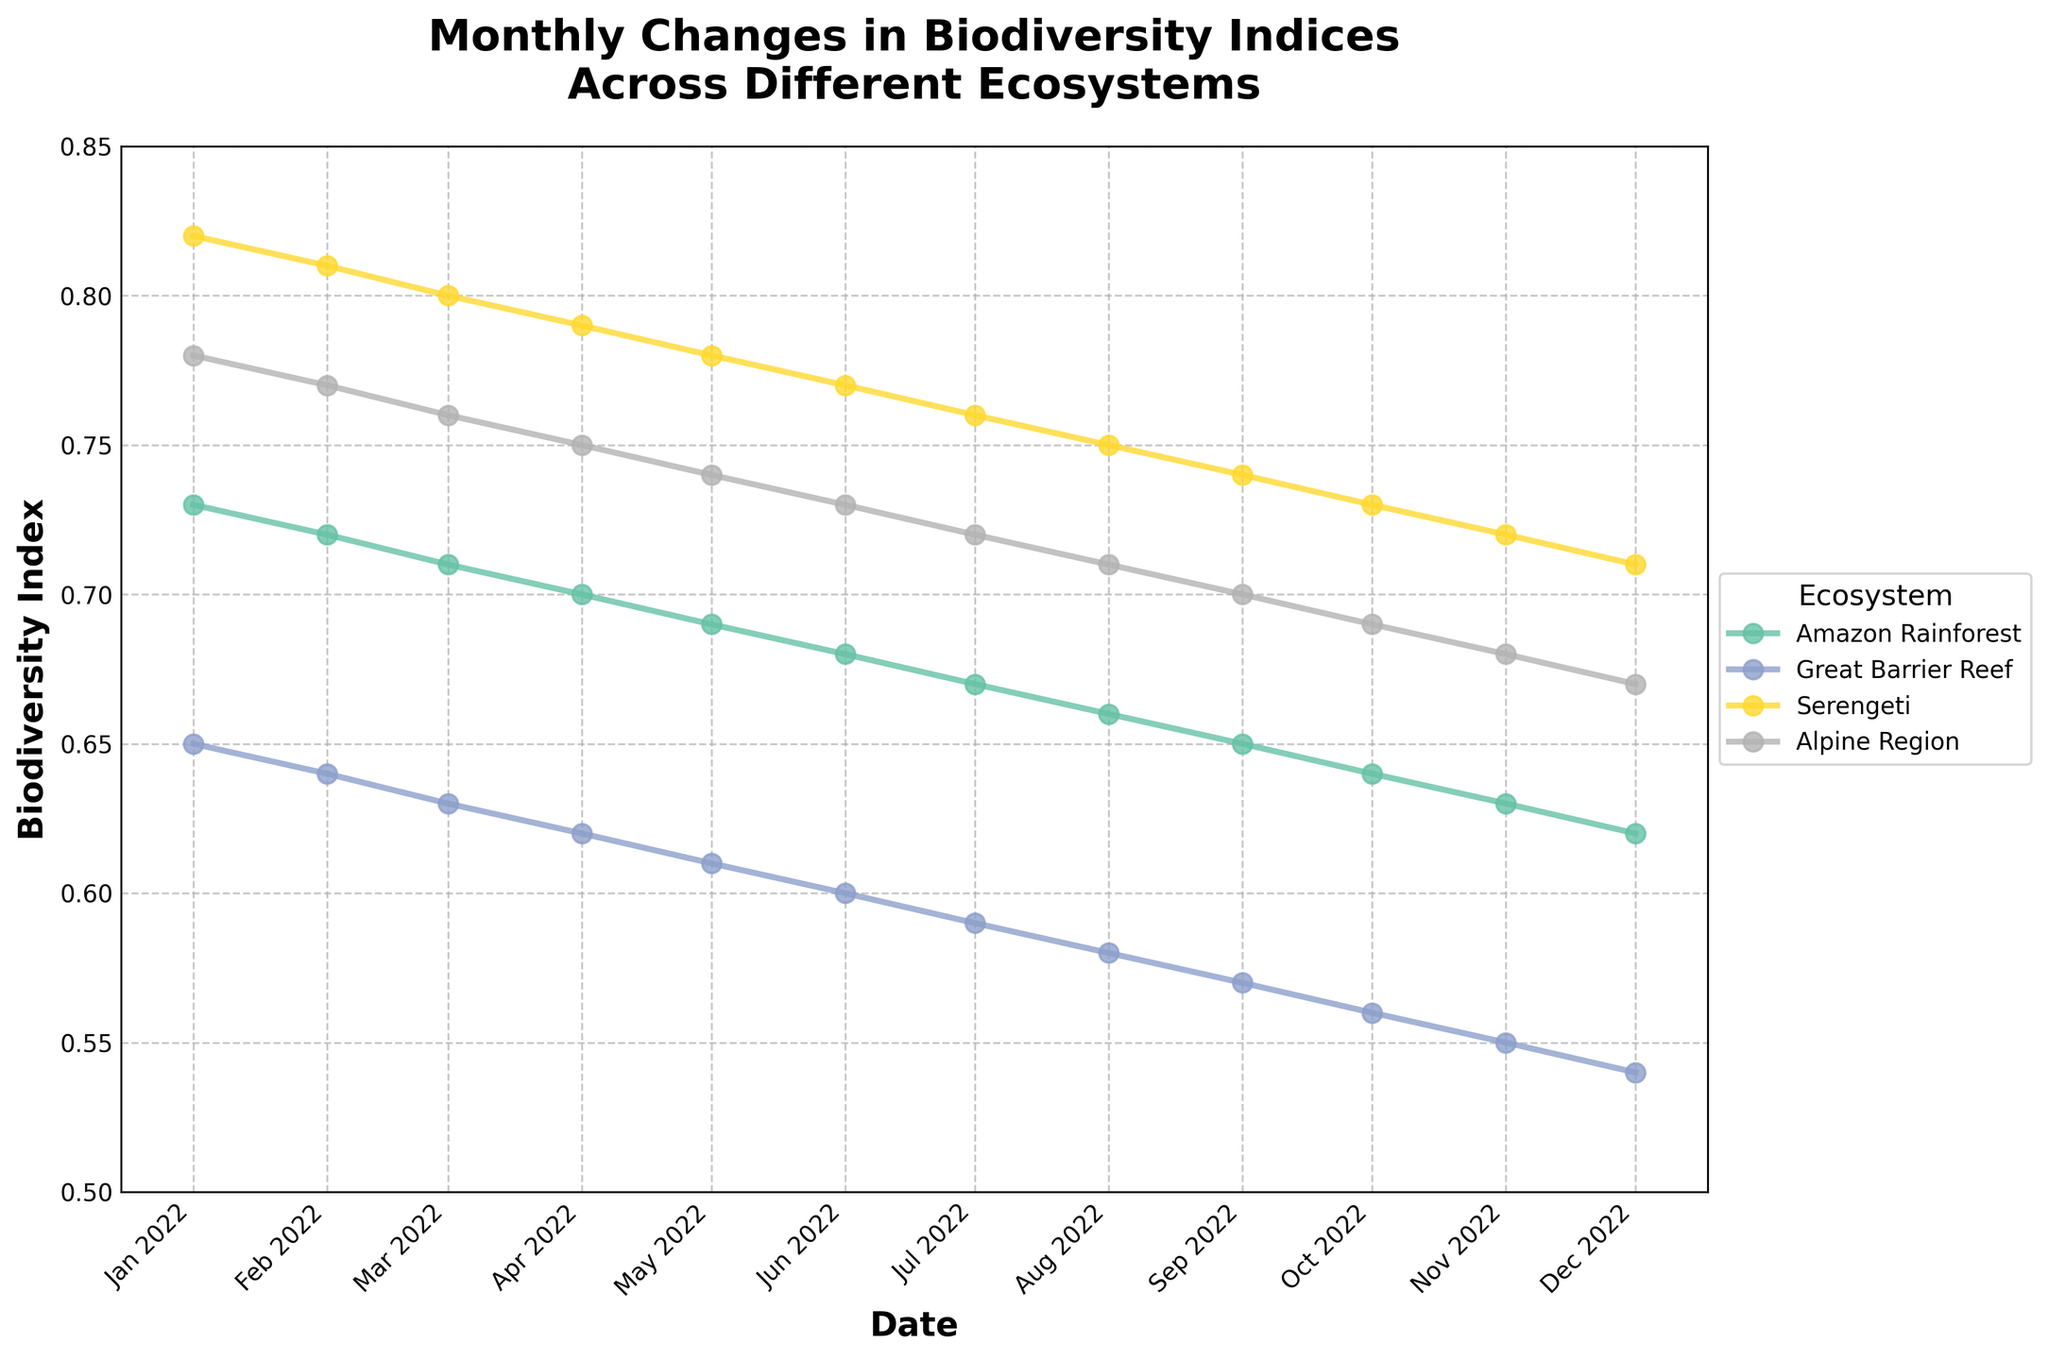What is the title of the plot? The title of the plot is shown at the top. The plot's title is: "Monthly Changes in Biodiversity Indices Across Different Ecosystems."
Answer: Monthly Changes in Biodiversity Indices Across Different Ecosystems How many ecosystems are represented in the plot? The plot legend lists all the ecosystems, and we can count how many are shown there. There are four ecosystems in total.
Answer: Four Which ecosystem shows the highest biodiversity index in January 2022? Looking at the January 2022 data points, we notice the Serengeti has the highest point at 0.82.
Answer: Serengeti What is the general trend of the biodiversity index for the Amazon Rainforest throughout the year? Observing the line for the Amazon Rainforest from January to December, we see a gradual and consistent decrease.
Answer: Gradual decrease Which ecosystem experienced the most significant drop in the biodiversity index over the year? By comparing the start and end values of biodiversity indices for each ecosystem, the Great Barrier Reef dropped from 0.65 in January to 0.54 in December, the most significant drop of 0.11.
Answer: Great Barrier Reef What is the approximate biodiversity index for the Alpine Region in July 2022? We locate the July 2022 point for the Alpine Region and see that the biodiversity index is around 0.72.
Answer: 0.72 Which months show the greatest difference in biodiversity index between the Amazon Rainforest and Great Barrier Reef? By comparing the two lines month by month, the largest difference occurs in January 2022, where the Amazon Rainforest is at 0.73 and the Great Barrier Reef is at 0.65, a difference of 0.08.
Answer: January 2022 Among the ecosystems, which one maintained the highest biodiversity index consistently throughout the year? By observing the relative positions of the plots throughout the year, the Serengeti maintained the highest biodiversity index consistently.
Answer: Serengeti What is the change in the biodiversity index for the Great Barrier Reef from June to July 2022? Observing the values for June and July for the Great Barrier Reef, we see the index changes from 0.60 to 0.59, a decrease of 0.01.
Answer: -0.01 Which month sees the smallest difference in biodiversity index between the Serengeti and Alpine Region? By analyzing the data points of both ecosystems month-wise, the smallest difference is in December 2022, where Serengeti is at 0.71, and Alpine Region is at 0.67, a difference of 0.04.
Answer: December 2022 